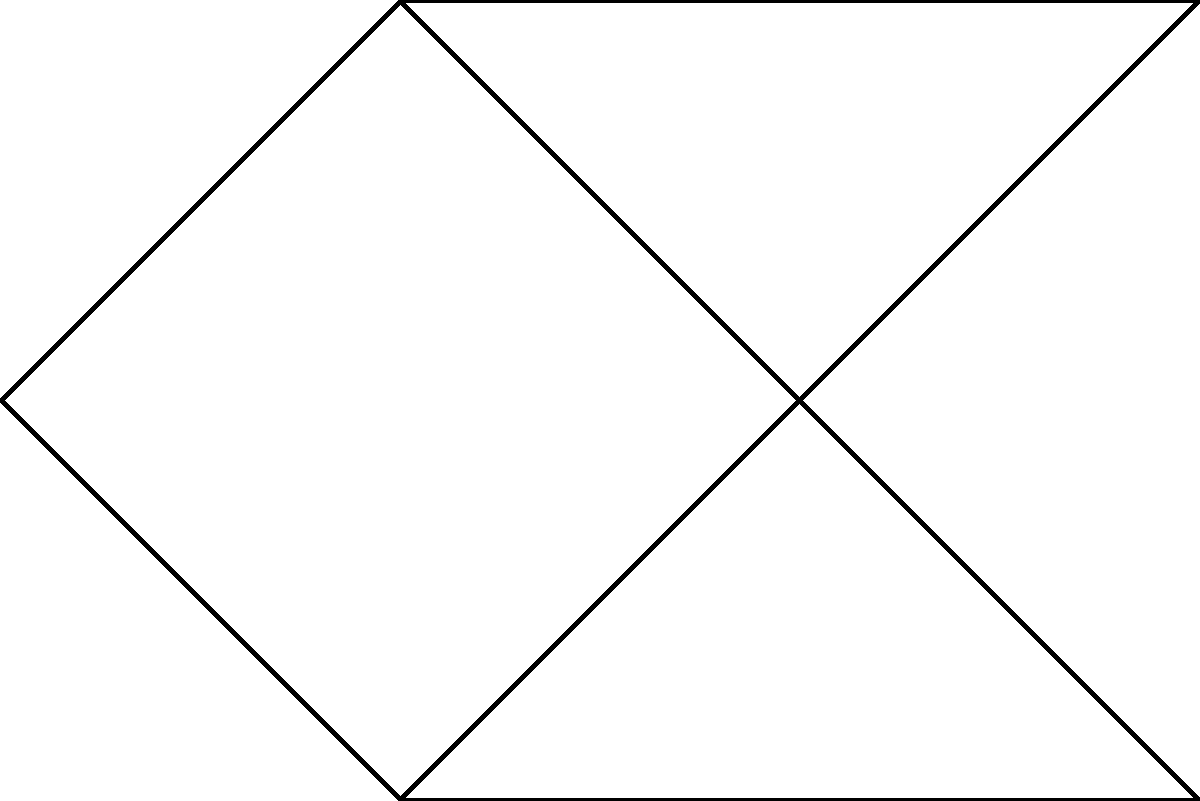Consider the planar graph shown above. What is the minimum number of colors needed to properly color the vertices of this graph such that no two adjacent vertices have the same color? To determine the minimum number of colors needed, we'll use the following steps based on graph coloring principles:

1) First, recall the Four Color Theorem, which states that any planar graph can be colored using at most four colors.

2) However, we need to find the minimum number of colors for this specific graph.

3) Let's try to color the graph systematically:
   - Start with $v_1$. We can color it with color 1.
   - $v_2$ is adjacent to $v_1$, so it needs a different color. Color it with color 2.
   - $v_3$ is adjacent to $v_2$, so it needs a different color. We can use color 1.
   - $v_4$ is adjacent to $v_1$ and $v_3$, so it needs a new color. Color it with color 3.
   - $v_5$ is adjacent to $v_2$ and $v_3$, so it needs a new color. Color it with color 3.
   - $v_6$ is adjacent to $v_3$ and $v_4$, so we can color it with color 2.

4) We've successfully colored the graph using only 3 colors.

5) To prove that 2 colors are not sufficient:
   - The subgraph formed by $v_1$, $v_2$, and $v_3$ forms a triangle.
   - A triangle always requires 3 colors for a proper coloring.

Therefore, the minimum number of colors needed is 3.
Answer: 3 colors 